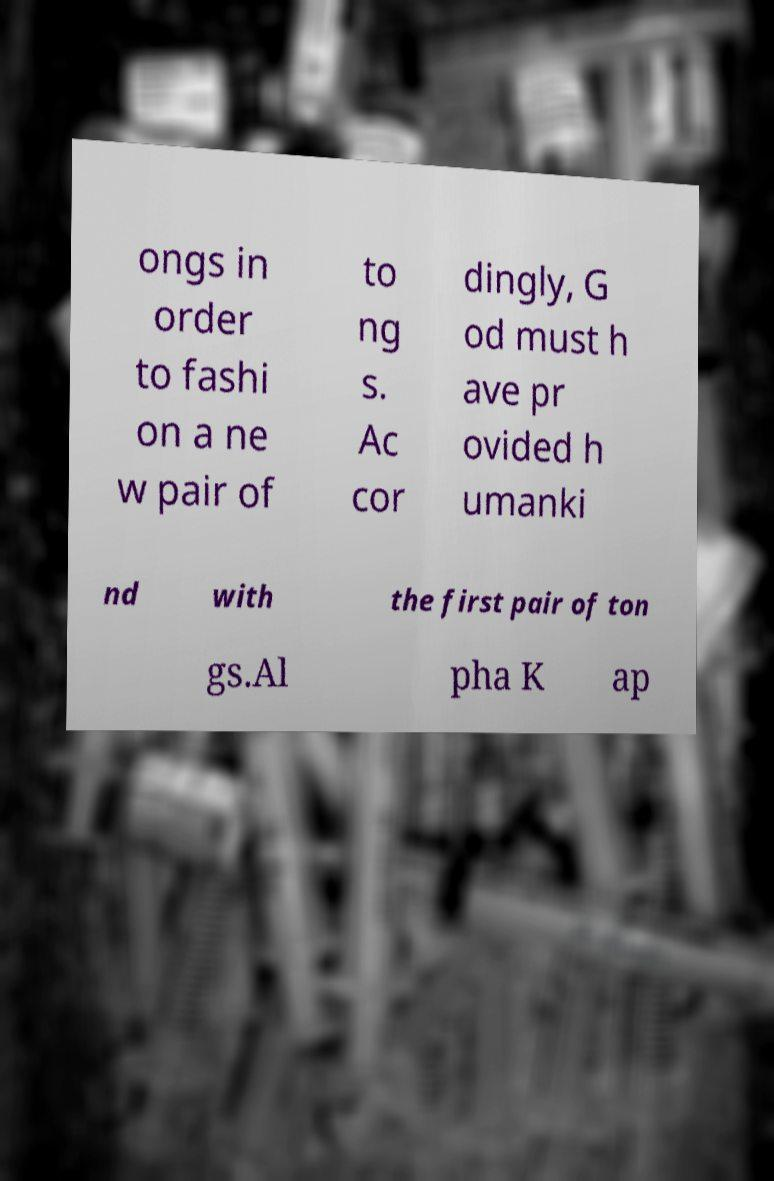Please read and relay the text visible in this image. What does it say? ongs in order to fashi on a ne w pair of to ng s. Ac cor dingly, G od must h ave pr ovided h umanki nd with the first pair of ton gs.Al pha K ap 